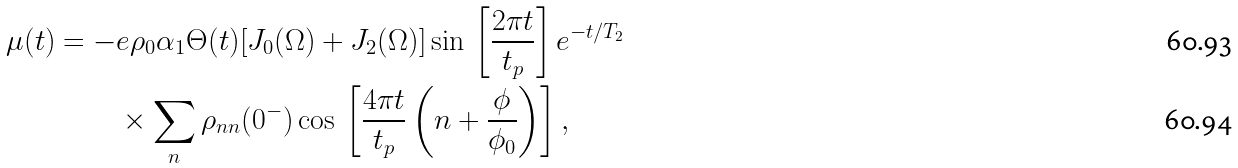<formula> <loc_0><loc_0><loc_500><loc_500>\mu ( t ) = - & e \rho _ { 0 } \alpha _ { 1 } \Theta ( t ) [ J _ { 0 } ( \Omega ) + J _ { 2 } ( \Omega ) ] \sin \, \left [ \frac { 2 \pi t } { t _ { p } } \right ] e ^ { - t / T _ { 2 } } \\ & \times \sum _ { n } \rho _ { n n } ( 0 ^ { - } ) \cos \, \left [ \frac { 4 \pi t } { t _ { p } } \left ( n + \frac { \phi } { \phi _ { 0 } } \right ) \right ] ,</formula> 